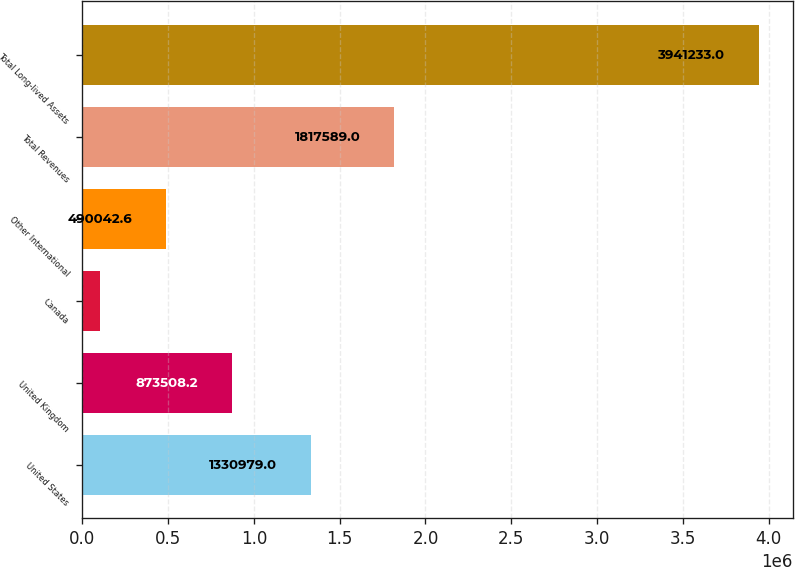<chart> <loc_0><loc_0><loc_500><loc_500><bar_chart><fcel>United States<fcel>United Kingdom<fcel>Canada<fcel>Other International<fcel>Total Revenues<fcel>Total Long-lived Assets<nl><fcel>1.33098e+06<fcel>873508<fcel>106577<fcel>490043<fcel>1.81759e+06<fcel>3.94123e+06<nl></chart> 